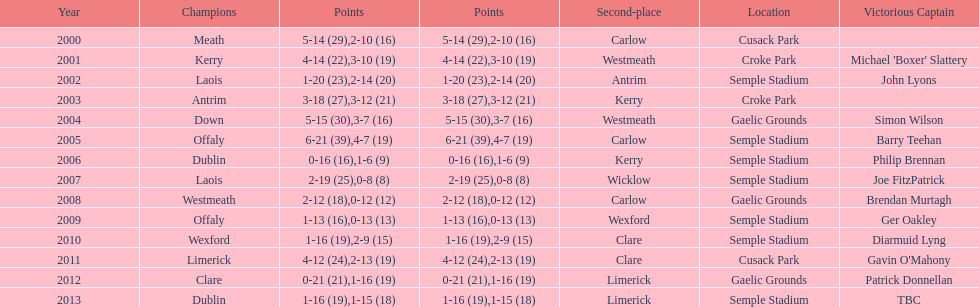What is the difference in the scores in 2000? 13. 